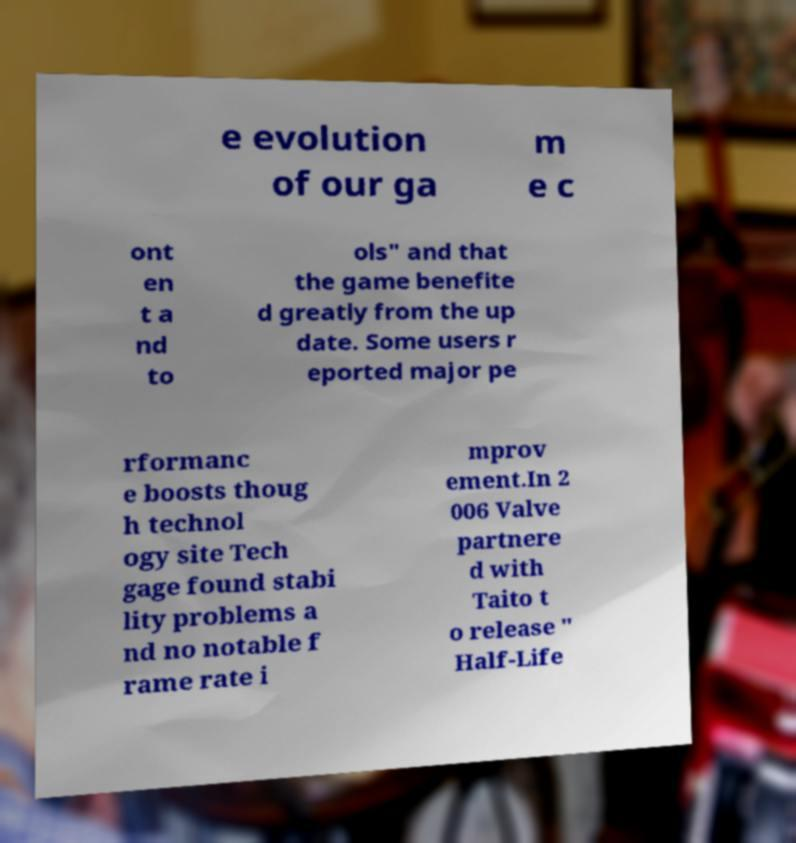Please identify and transcribe the text found in this image. e evolution of our ga m e c ont en t a nd to ols" and that the game benefite d greatly from the up date. Some users r eported major pe rformanc e boosts thoug h technol ogy site Tech gage found stabi lity problems a nd no notable f rame rate i mprov ement.In 2 006 Valve partnere d with Taito t o release " Half-Life 